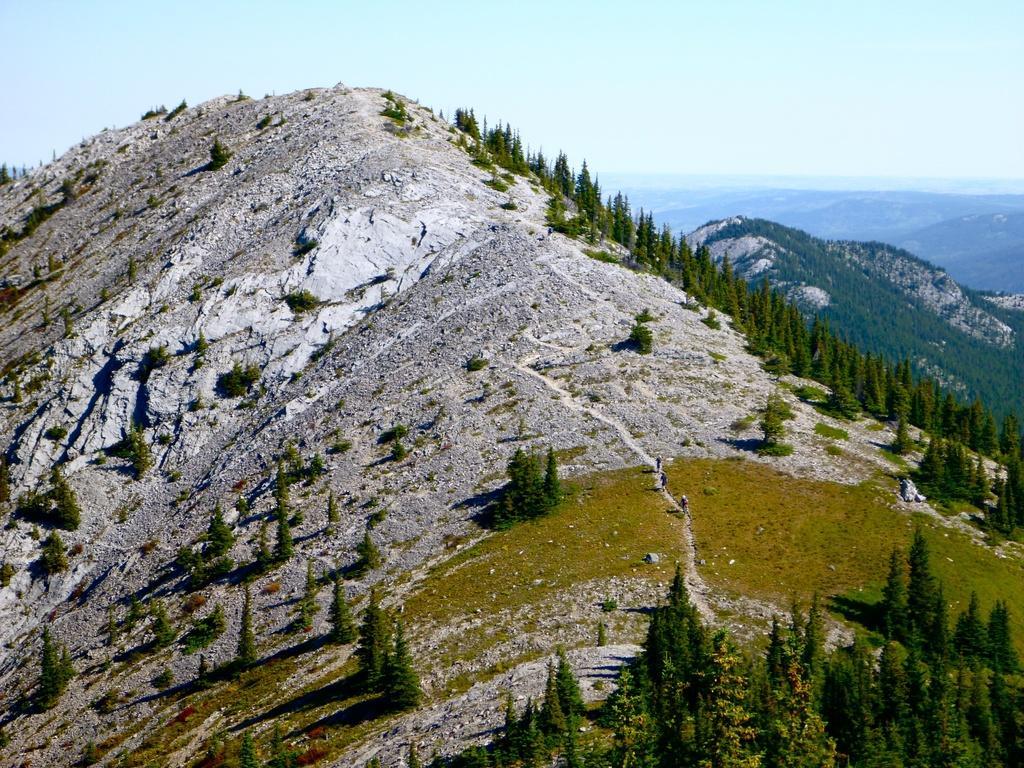Please provide a concise description of this image. It is the picture of of mountain, there are three people walking on the mountain, there are also a lot of trees and in the background there are many other mountains. 